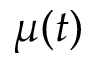<formula> <loc_0><loc_0><loc_500><loc_500>\mu ( t )</formula> 